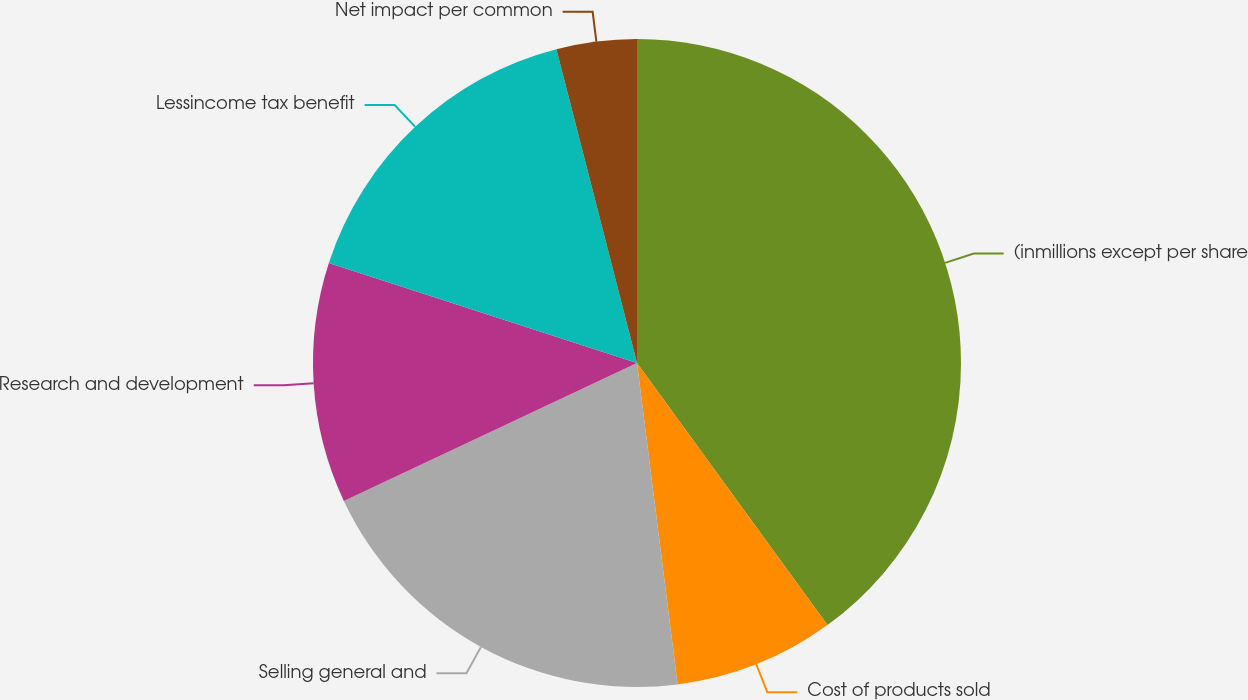Convert chart to OTSL. <chart><loc_0><loc_0><loc_500><loc_500><pie_chart><fcel>(inmillions except per share<fcel>Cost of products sold<fcel>Selling general and<fcel>Research and development<fcel>Lessincome tax benefit<fcel>Net impact per common<nl><fcel>40.0%<fcel>8.0%<fcel>20.0%<fcel>12.0%<fcel>16.0%<fcel>4.0%<nl></chart> 